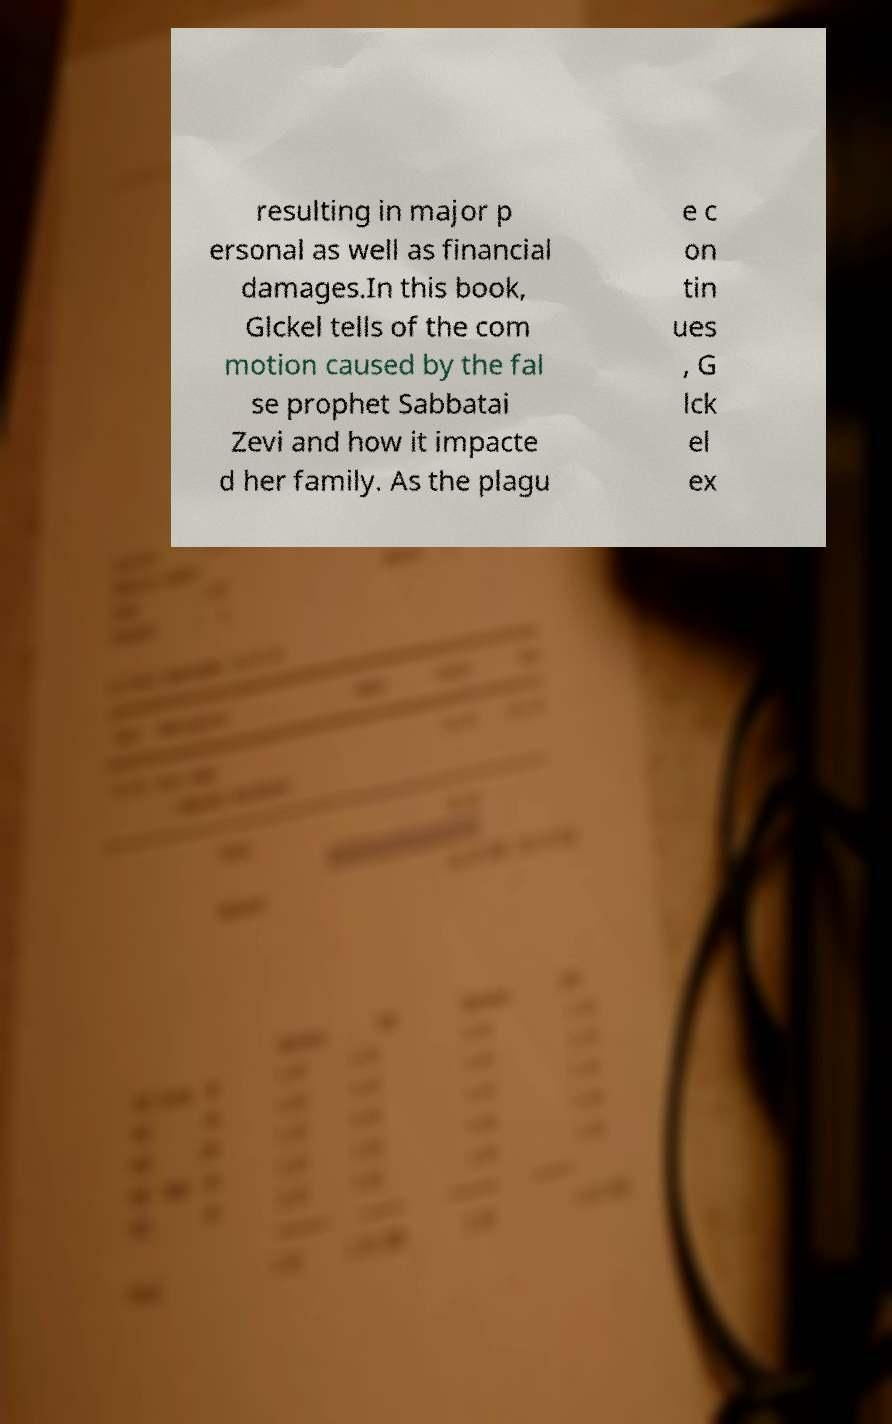Could you extract and type out the text from this image? resulting in major p ersonal as well as financial damages.In this book, Glckel tells of the com motion caused by the fal se prophet Sabbatai Zevi and how it impacte d her family. As the plagu e c on tin ues , G lck el ex 